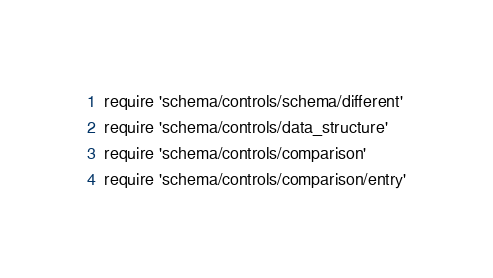<code> <loc_0><loc_0><loc_500><loc_500><_Ruby_>require 'schema/controls/schema/different'
require 'schema/controls/data_structure'
require 'schema/controls/comparison'
require 'schema/controls/comparison/entry'
</code> 